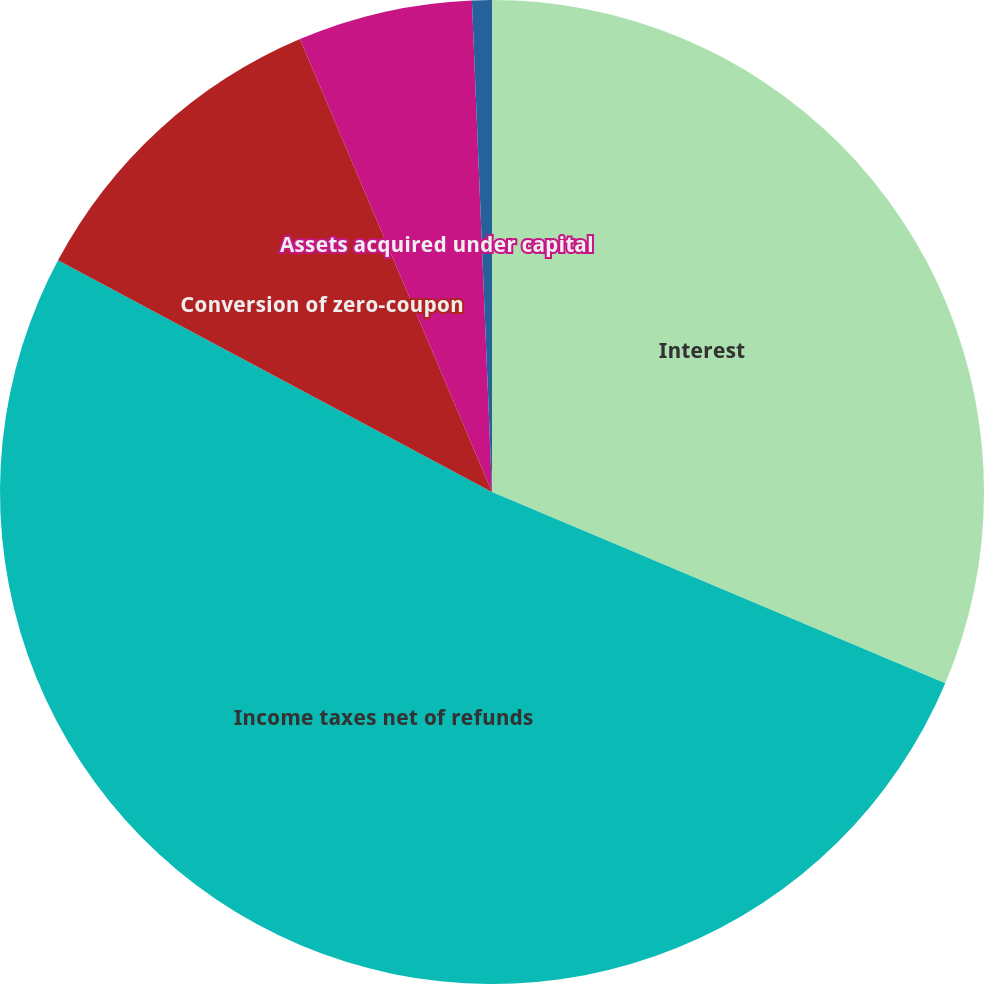<chart> <loc_0><loc_0><loc_500><loc_500><pie_chart><fcel>Interest<fcel>Income taxes net of refunds<fcel>Conversion of zero-coupon<fcel>Assets acquired under capital<fcel>Accrued property plant and<nl><fcel>31.35%<fcel>51.44%<fcel>10.81%<fcel>5.73%<fcel>0.65%<nl></chart> 